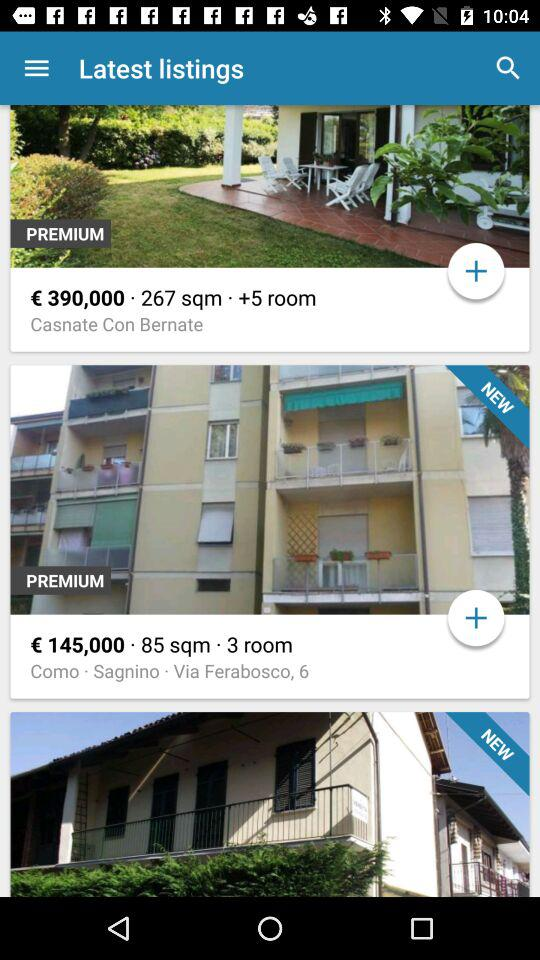What is the price of the house with +5 rooms? The price of the house is €390,000. 